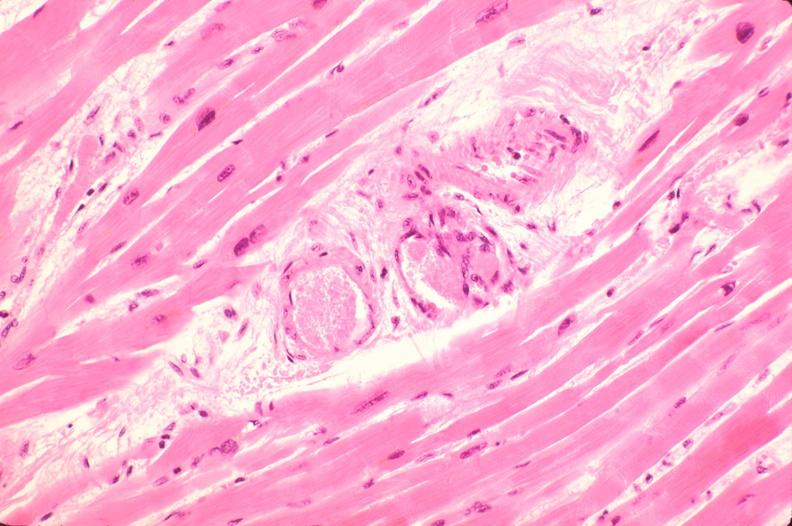where is this in?
Answer the question using a single word or phrase. In heart 